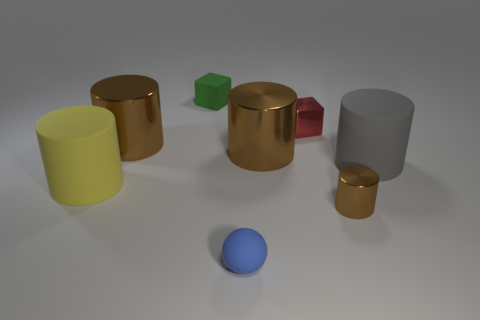There is a blue object that is the same size as the red shiny cube; what shape is it?
Ensure brevity in your answer.  Sphere. Is the size of the rubber cylinder that is to the right of the blue object the same as the small red metallic thing?
Give a very brief answer. No. What is the material of the yellow cylinder that is the same size as the gray thing?
Give a very brief answer. Rubber. There is a big matte cylinder that is right of the large shiny thing that is to the left of the sphere; is there a blue ball that is behind it?
Give a very brief answer. No. Is there any other thing that has the same shape as the tiny brown object?
Offer a terse response. Yes. Does the tiny metallic thing in front of the yellow rubber thing have the same color as the big matte thing that is left of the red object?
Your response must be concise. No. Are any metal cylinders visible?
Offer a terse response. Yes. There is a matte object in front of the brown cylinder in front of the matte cylinder that is to the right of the small brown metallic thing; what size is it?
Offer a very short reply. Small. There is a large yellow object; is its shape the same as the brown metallic thing that is to the left of the green rubber block?
Provide a short and direct response. Yes. Is there a big rubber cylinder that has the same color as the ball?
Your response must be concise. No. 